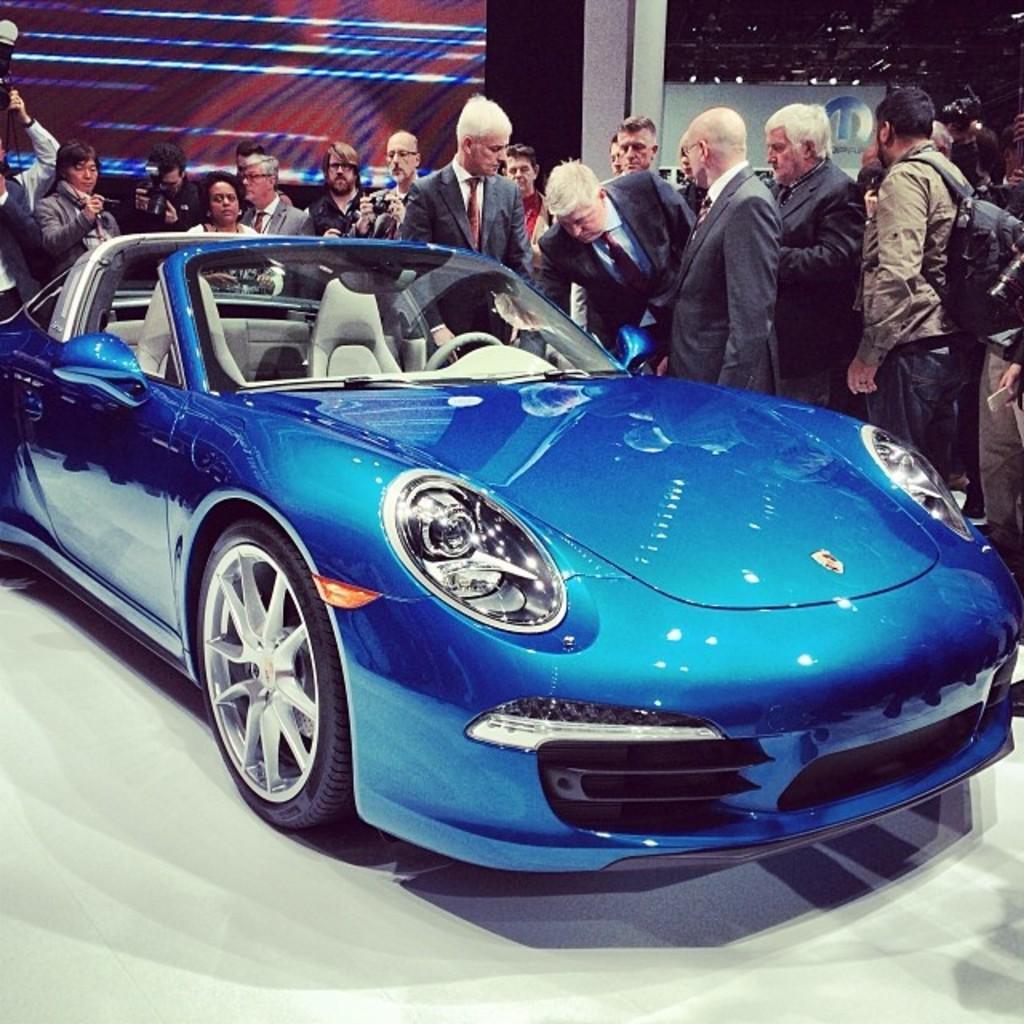In one or two sentences, can you explain what this image depicts? In the center of the image, we can see a car and in the background, there are many people standing and we can see a wall. 